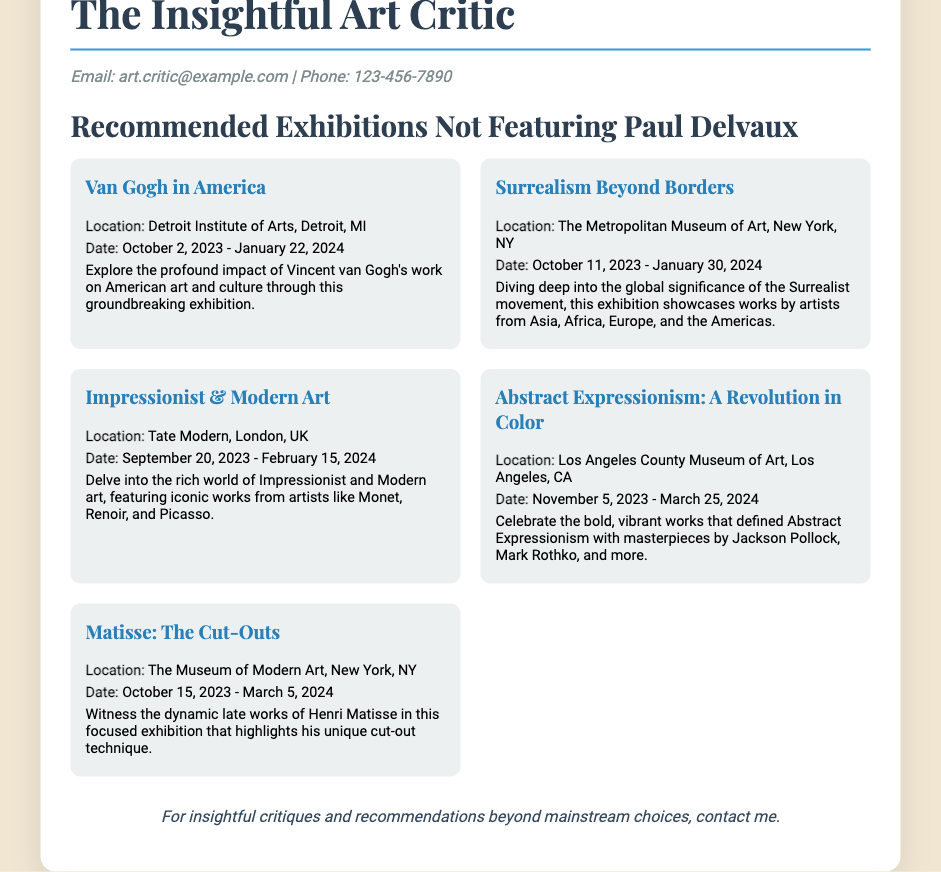What is the title of the first recommended exhibition? The title of the first recommended exhibition is listed prominently under the exhibitions section.
Answer: Van Gogh in America What is the location of the exhibition "Surrealism Beyond Borders"? The location is specifically mentioned alongside the exhibition title.
Answer: The Metropolitan Museum of Art, New York, NY What is the end date of the "Impressionist & Modern Art" exhibition? The end date is provided in the details of the exhibition description.
Answer: February 15, 2024 How many exhibitions are recommended in total? The number of exhibitions can be counted from the list; there are a total of five exhibitions featured.
Answer: 5 What is a key theme of the exhibition "Abstract Expressionism: A Revolution in Color"? The theme is summarized in the description of the exhibition.
Answer: Bold, vibrant works Who can be contacted for critiques and recommendations? The contact information is provided in the document, and it indicates who to reach out to.
Answer: The Insightful Art Critic 